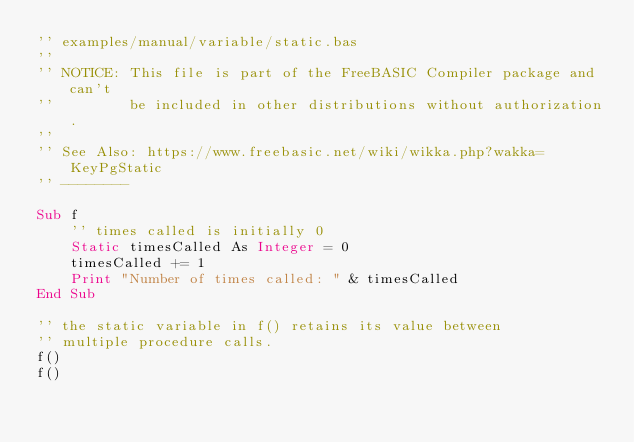Convert code to text. <code><loc_0><loc_0><loc_500><loc_500><_VisualBasic_>'' examples/manual/variable/static.bas
''
'' NOTICE: This file is part of the FreeBASIC Compiler package and can't
''         be included in other distributions without authorization.
''
'' See Also: https://www.freebasic.net/wiki/wikka.php?wakka=KeyPgStatic
'' --------

Sub f
	'' times called is initially 0
	Static timesCalled As Integer = 0
	timesCalled += 1
	Print "Number of times called: " & timesCalled
End Sub

'' the static variable in f() retains its value between
'' multiple procedure calls.
f()
f()
</code> 